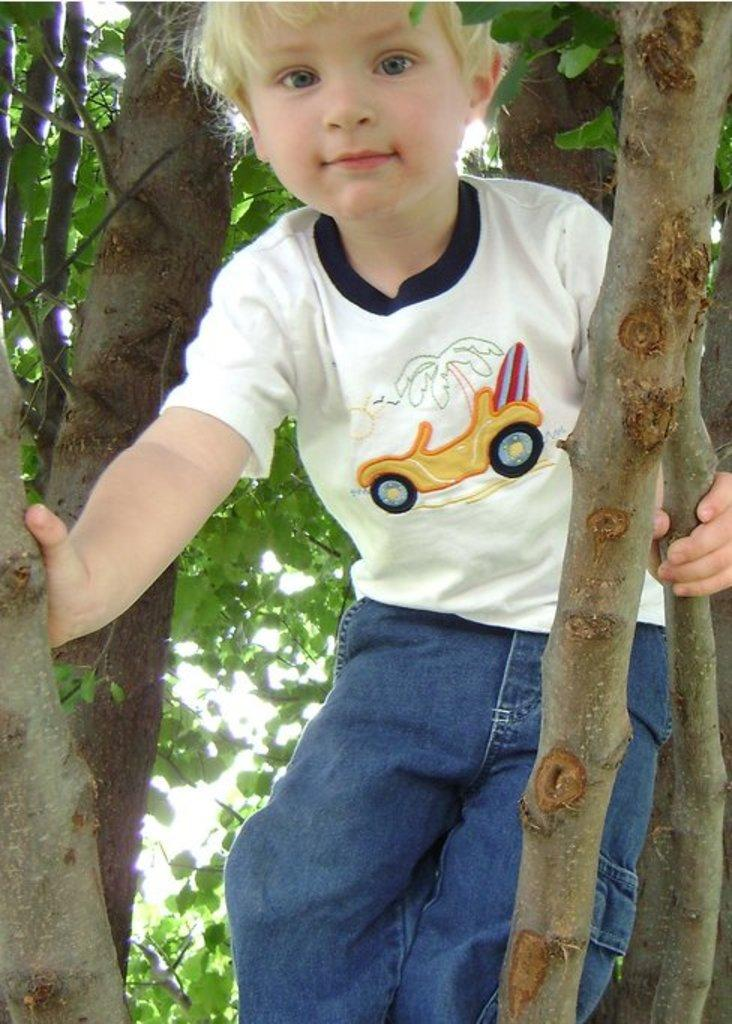What is the main subject of the image? The main subject of the image is a kid. Where is the kid located in the image? The kid is on a tree. What type of art can be heard in the image? There is no art or sound present in the image; it is a visual representation of a kid on a tree. 